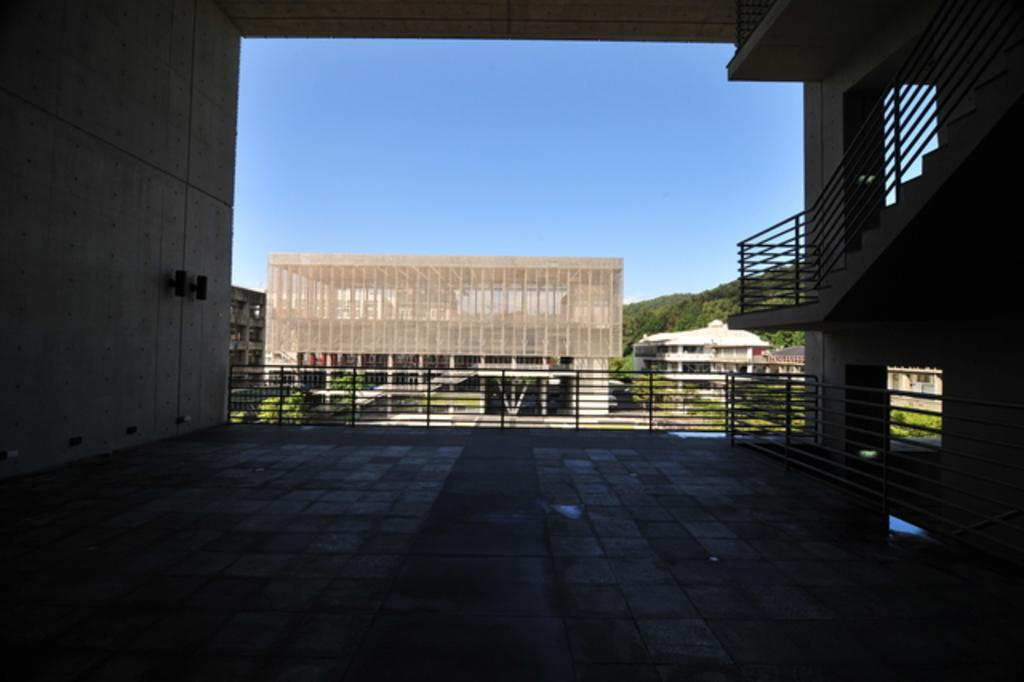What is located in the foreground of the image? In the foreground of the image, there is a pavement, a deck rail, a staircase, and a hand rail. Can you describe the elements in the foreground of the image? The foreground features a pavement, a deck rail, a staircase, and a hand rail. What can be seen in the background of the image? In the background of the image, there are trees, buildings, and plants. What is visible in the sky in the background of the image? The sky is visible in the background of the image. What is the level of interest in the image? The provided facts do not mention any specific interest or level of interest, so it cannot be determined from the image. 